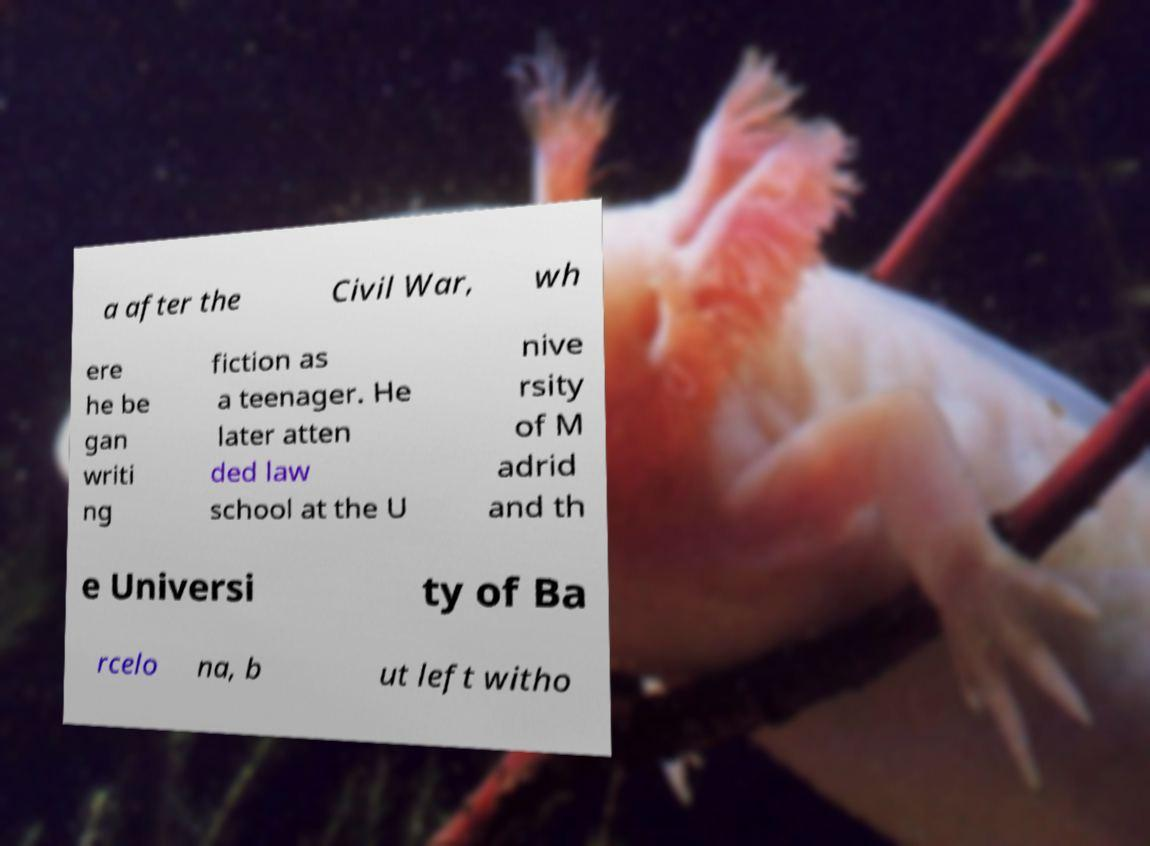Can you read and provide the text displayed in the image?This photo seems to have some interesting text. Can you extract and type it out for me? a after the Civil War, wh ere he be gan writi ng fiction as a teenager. He later atten ded law school at the U nive rsity of M adrid and th e Universi ty of Ba rcelo na, b ut left witho 